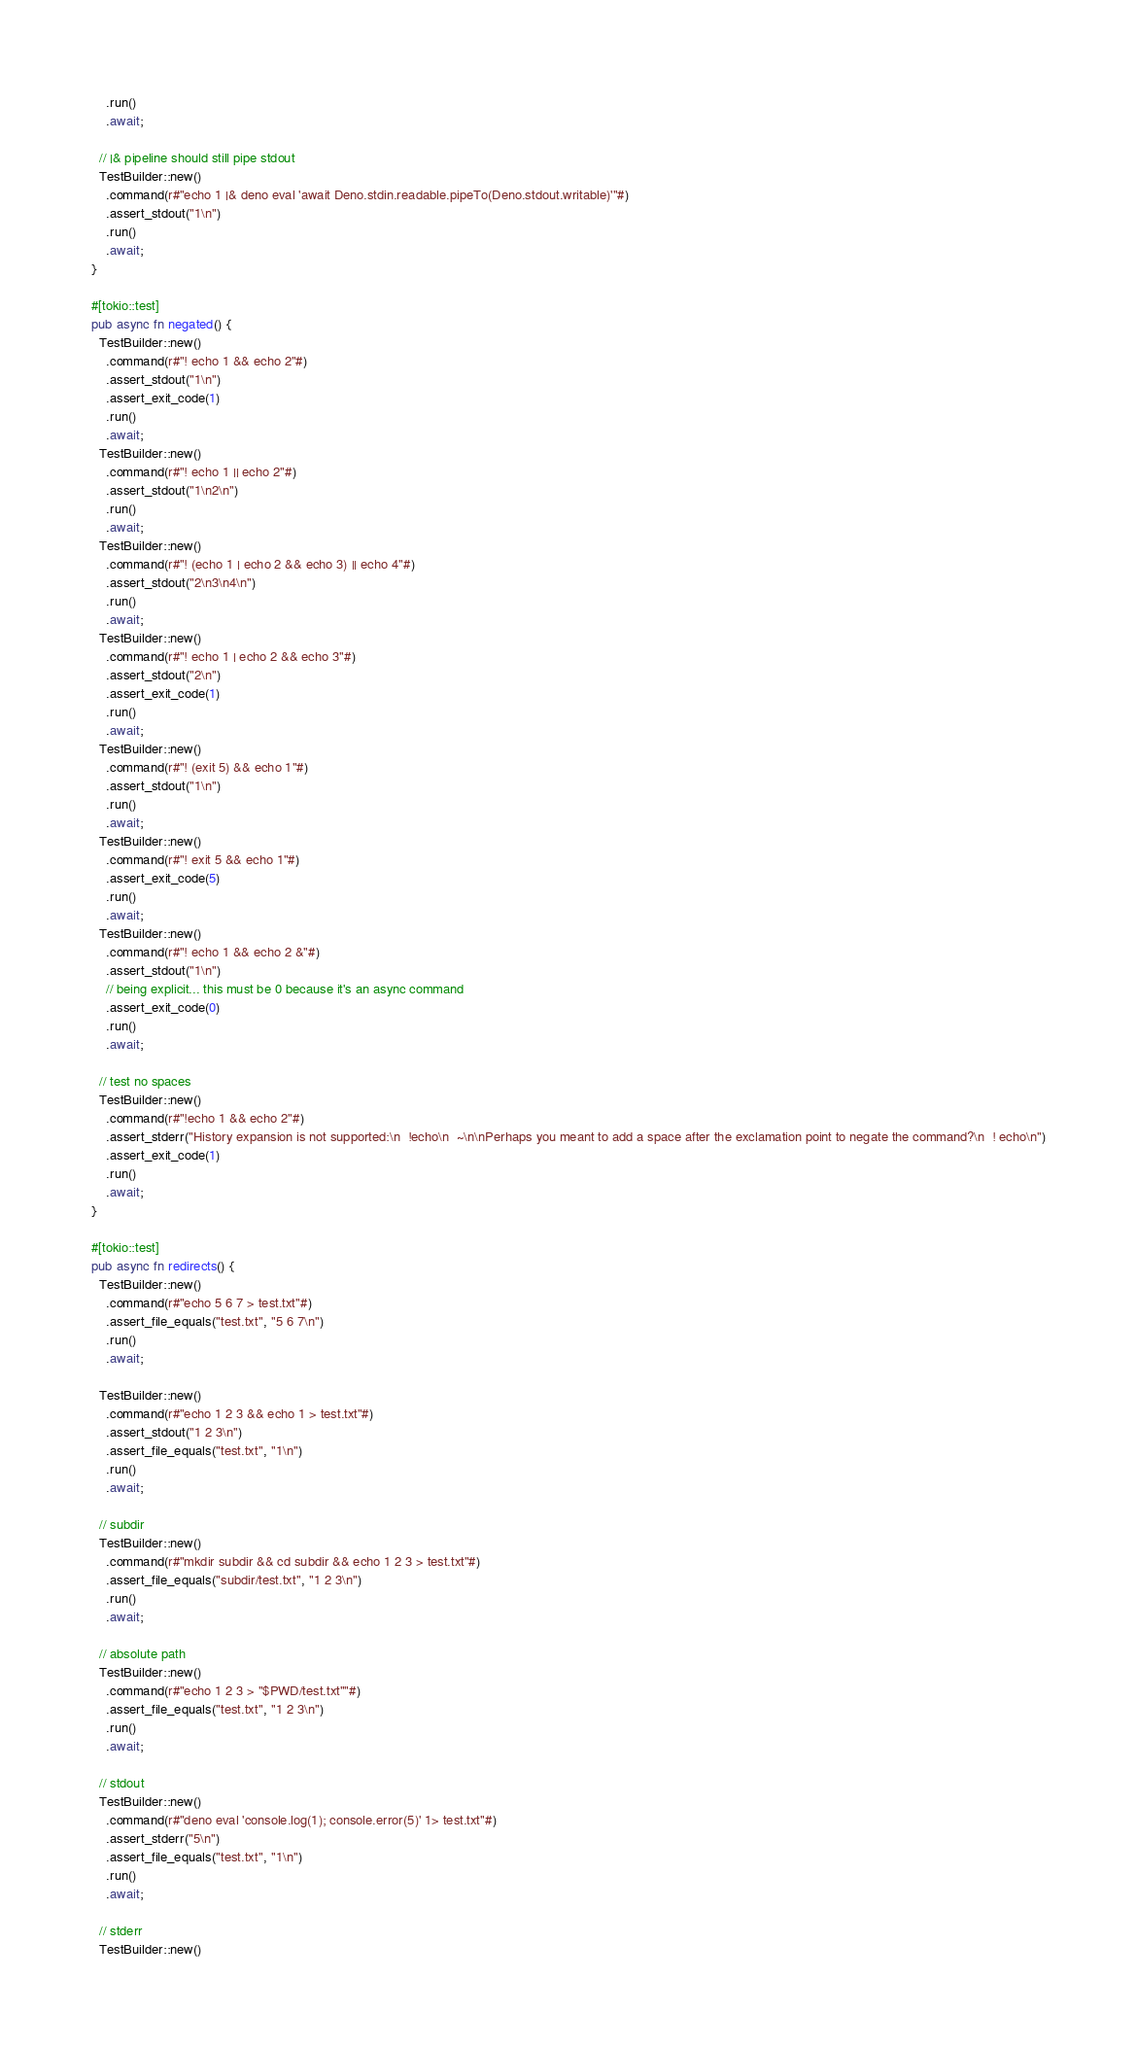<code> <loc_0><loc_0><loc_500><loc_500><_Rust_>    .run()
    .await;

  // |& pipeline should still pipe stdout
  TestBuilder::new()
    .command(r#"echo 1 |& deno eval 'await Deno.stdin.readable.pipeTo(Deno.stdout.writable)'"#)
    .assert_stdout("1\n")
    .run()
    .await;
}

#[tokio::test]
pub async fn negated() {
  TestBuilder::new()
    .command(r#"! echo 1 && echo 2"#)
    .assert_stdout("1\n")
    .assert_exit_code(1)
    .run()
    .await;
  TestBuilder::new()
    .command(r#"! echo 1 || echo 2"#)
    .assert_stdout("1\n2\n")
    .run()
    .await;
  TestBuilder::new()
    .command(r#"! (echo 1 | echo 2 && echo 3) || echo 4"#)
    .assert_stdout("2\n3\n4\n")
    .run()
    .await;
  TestBuilder::new()
    .command(r#"! echo 1 | echo 2 && echo 3"#)
    .assert_stdout("2\n")
    .assert_exit_code(1)
    .run()
    .await;
  TestBuilder::new()
    .command(r#"! (exit 5) && echo 1"#)
    .assert_stdout("1\n")
    .run()
    .await;
  TestBuilder::new()
    .command(r#"! exit 5 && echo 1"#)
    .assert_exit_code(5)
    .run()
    .await;
  TestBuilder::new()
    .command(r#"! echo 1 && echo 2 &"#)
    .assert_stdout("1\n")
    // being explicit... this must be 0 because it's an async command
    .assert_exit_code(0)
    .run()
    .await;

  // test no spaces
  TestBuilder::new()
    .command(r#"!echo 1 && echo 2"#)
    .assert_stderr("History expansion is not supported:\n  !echo\n  ~\n\nPerhaps you meant to add a space after the exclamation point to negate the command?\n  ! echo\n")
    .assert_exit_code(1)
    .run()
    .await;
}

#[tokio::test]
pub async fn redirects() {
  TestBuilder::new()
    .command(r#"echo 5 6 7 > test.txt"#)
    .assert_file_equals("test.txt", "5 6 7\n")
    .run()
    .await;

  TestBuilder::new()
    .command(r#"echo 1 2 3 && echo 1 > test.txt"#)
    .assert_stdout("1 2 3\n")
    .assert_file_equals("test.txt", "1\n")
    .run()
    .await;

  // subdir
  TestBuilder::new()
    .command(r#"mkdir subdir && cd subdir && echo 1 2 3 > test.txt"#)
    .assert_file_equals("subdir/test.txt", "1 2 3\n")
    .run()
    .await;

  // absolute path
  TestBuilder::new()
    .command(r#"echo 1 2 3 > "$PWD/test.txt""#)
    .assert_file_equals("test.txt", "1 2 3\n")
    .run()
    .await;

  // stdout
  TestBuilder::new()
    .command(r#"deno eval 'console.log(1); console.error(5)' 1> test.txt"#)
    .assert_stderr("5\n")
    .assert_file_equals("test.txt", "1\n")
    .run()
    .await;

  // stderr
  TestBuilder::new()</code> 